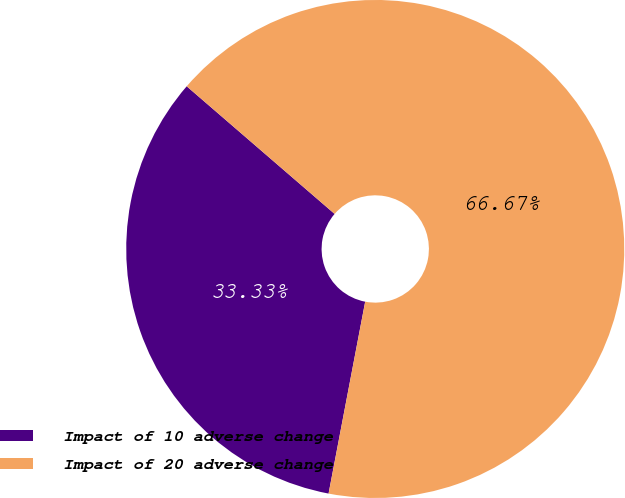Convert chart to OTSL. <chart><loc_0><loc_0><loc_500><loc_500><pie_chart><fcel>Impact of 10 adverse change<fcel>Impact of 20 adverse change<nl><fcel>33.33%<fcel>66.67%<nl></chart> 